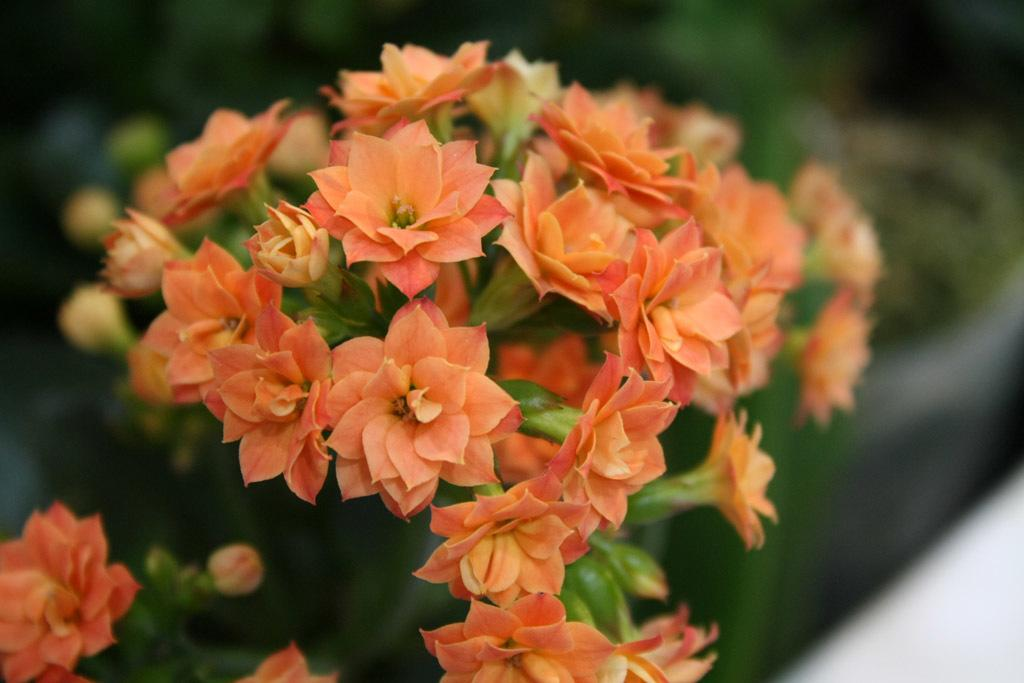What type of flowers are in the foreground of the picture? There are orange flowers in the foreground of the picture. What stage of growth are the orange flowers in? The orange flowers have buds on them. Can you describe the background of the image? The background of the image is blurred. What else can be seen in the background of the image? There are plants in the background of the image. What type of board is being offered to the orange flowers in the image? There is no board or offer present in the image; it features orange flowers with buds in the foreground and blurred plants in the background. 